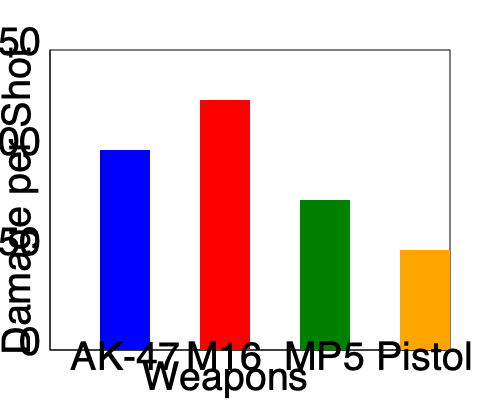In the bar graph showing weapon damage statistics from a popular Black Ops game, which weapon has the highest damage per shot, and what is the approximate difference in damage between this weapon and the pistol? To answer this question, we need to analyze the bar graph and follow these steps:

1. Identify the weapon with the highest damage:
   - AK-47 (blue bar): approximately 100 damage
   - M16 (red bar): approximately 125 damage
   - MP5 (green bar): approximately 75 damage
   - Pistol (orange bar): approximately 50 damage

   The M16 has the tallest bar, indicating the highest damage per shot.

2. Calculate the difference between the M16 and the pistol:
   - M16 damage: approximately 125
   - Pistol damage: approximately 50
   - Difference: $125 - 50 = 75$

Therefore, the M16 has the highest damage per shot, and the approximate difference in damage between the M16 and the pistol is 75 units.
Answer: M16; 75 damage units 